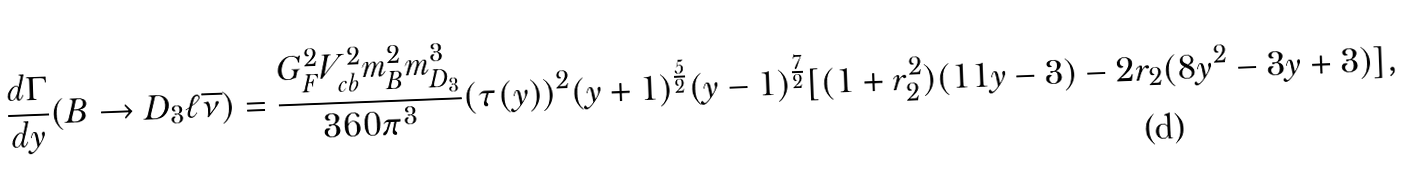<formula> <loc_0><loc_0><loc_500><loc_500>\frac { d \Gamma } { d y } ( B \rightarrow D _ { 3 } \ell \overline { \nu } ) = \frac { G ^ { 2 } _ { F } V ^ { 2 } _ { c b } m ^ { 2 } _ { B } m ^ { 3 } _ { D _ { 3 } } } { 3 6 0 \pi ^ { 3 } } ( \tau ( y ) ) ^ { 2 } ( y + 1 ) ^ { \frac { 5 } { 2 } } ( y - 1 ) ^ { \frac { 7 } { 2 } } [ ( 1 + r _ { 2 } ^ { 2 } ) ( 1 1 y - 3 ) - 2 r _ { 2 } ( 8 y ^ { 2 } - 3 y + 3 ) ] ,</formula> 